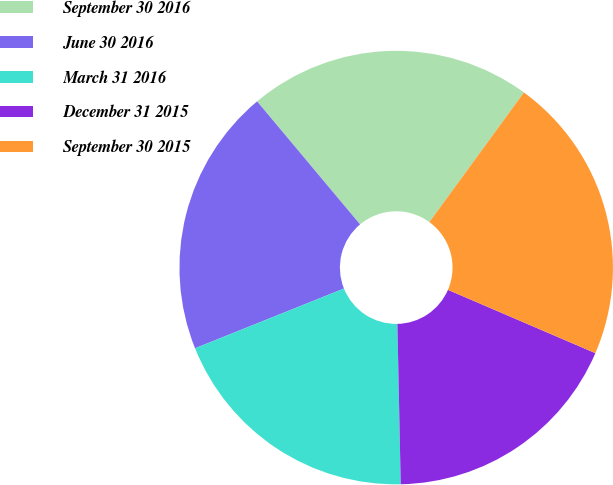Convert chart to OTSL. <chart><loc_0><loc_0><loc_500><loc_500><pie_chart><fcel>September 30 2016<fcel>June 30 2016<fcel>March 31 2016<fcel>December 31 2015<fcel>September 30 2015<nl><fcel>21.12%<fcel>19.98%<fcel>19.26%<fcel>18.21%<fcel>21.43%<nl></chart> 